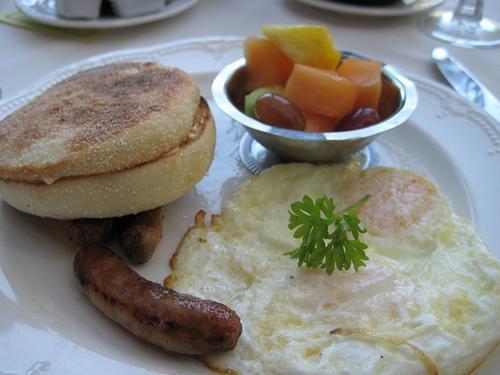How many grapes do you see?
Give a very brief answer. 2. How many eggs have been fired?
Give a very brief answer. 2. How many sandwiches can be seen?
Give a very brief answer. 1. How many bowls are there?
Give a very brief answer. 1. 